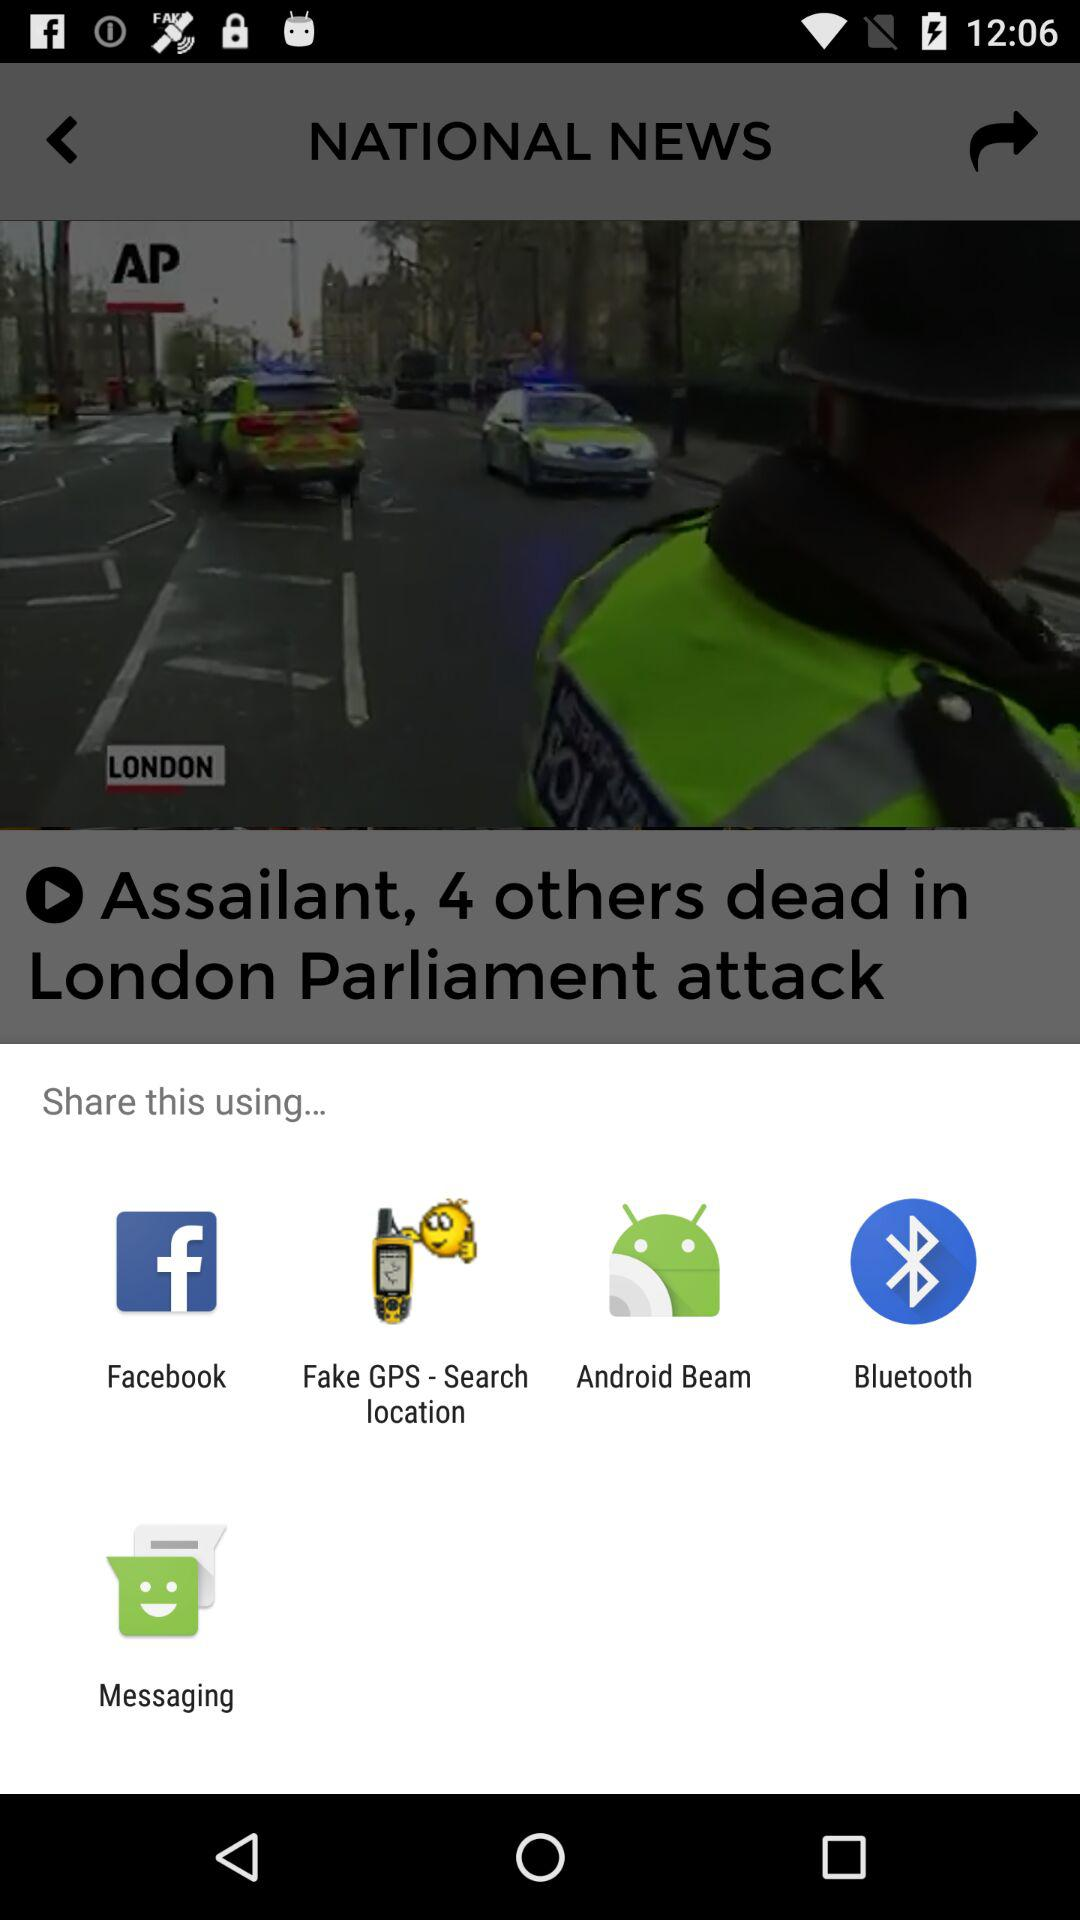Through which app can we share? You can share through "Facebook", "Fake GPS - Search location", "Android Beam", "Bluetooth" and "Messaging". 